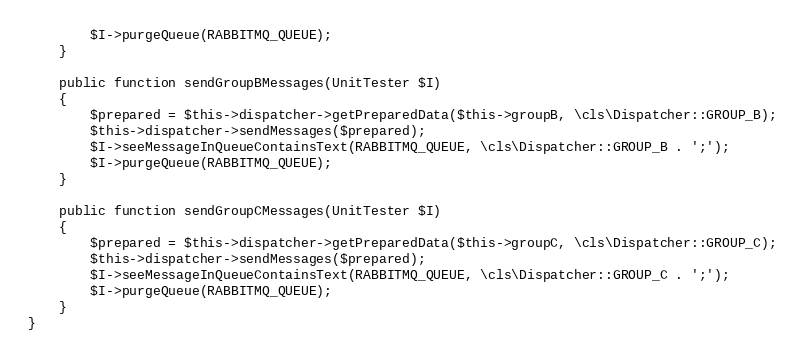Convert code to text. <code><loc_0><loc_0><loc_500><loc_500><_PHP_>        $I->purgeQueue(RABBITMQ_QUEUE);
    }

    public function sendGroupBMessages(UnitTester $I)
    {
        $prepared = $this->dispatcher->getPreparedData($this->groupB, \cls\Dispatcher::GROUP_B);
        $this->dispatcher->sendMessages($prepared);
        $I->seeMessageInQueueContainsText(RABBITMQ_QUEUE, \cls\Dispatcher::GROUP_B . ';');
        $I->purgeQueue(RABBITMQ_QUEUE);
    }

    public function sendGroupCMessages(UnitTester $I)
    {
        $prepared = $this->dispatcher->getPreparedData($this->groupC, \cls\Dispatcher::GROUP_C);
        $this->dispatcher->sendMessages($prepared);
        $I->seeMessageInQueueContainsText(RABBITMQ_QUEUE, \cls\Dispatcher::GROUP_C . ';');
        $I->purgeQueue(RABBITMQ_QUEUE);
    }
}
</code> 